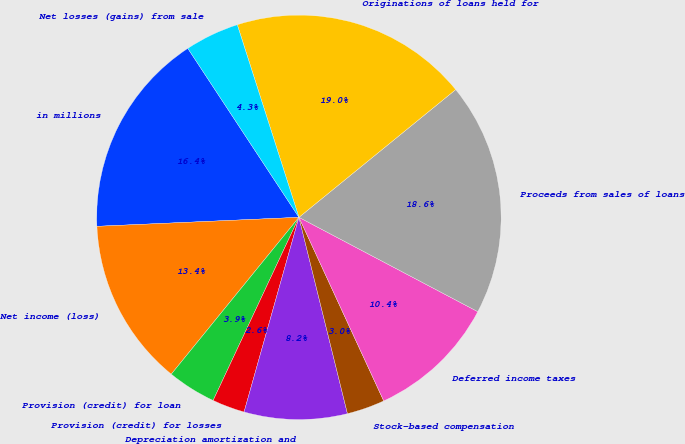Convert chart to OTSL. <chart><loc_0><loc_0><loc_500><loc_500><pie_chart><fcel>in millions<fcel>Net income (loss)<fcel>Provision (credit) for loan<fcel>Provision (credit) for losses<fcel>Depreciation amortization and<fcel>Stock-based compensation<fcel>Deferred income taxes<fcel>Proceeds from sales of loans<fcel>Originations of loans held for<fcel>Net losses (gains) from sale<nl><fcel>16.45%<fcel>13.42%<fcel>3.9%<fcel>2.6%<fcel>8.23%<fcel>3.03%<fcel>10.39%<fcel>18.61%<fcel>19.05%<fcel>4.33%<nl></chart> 